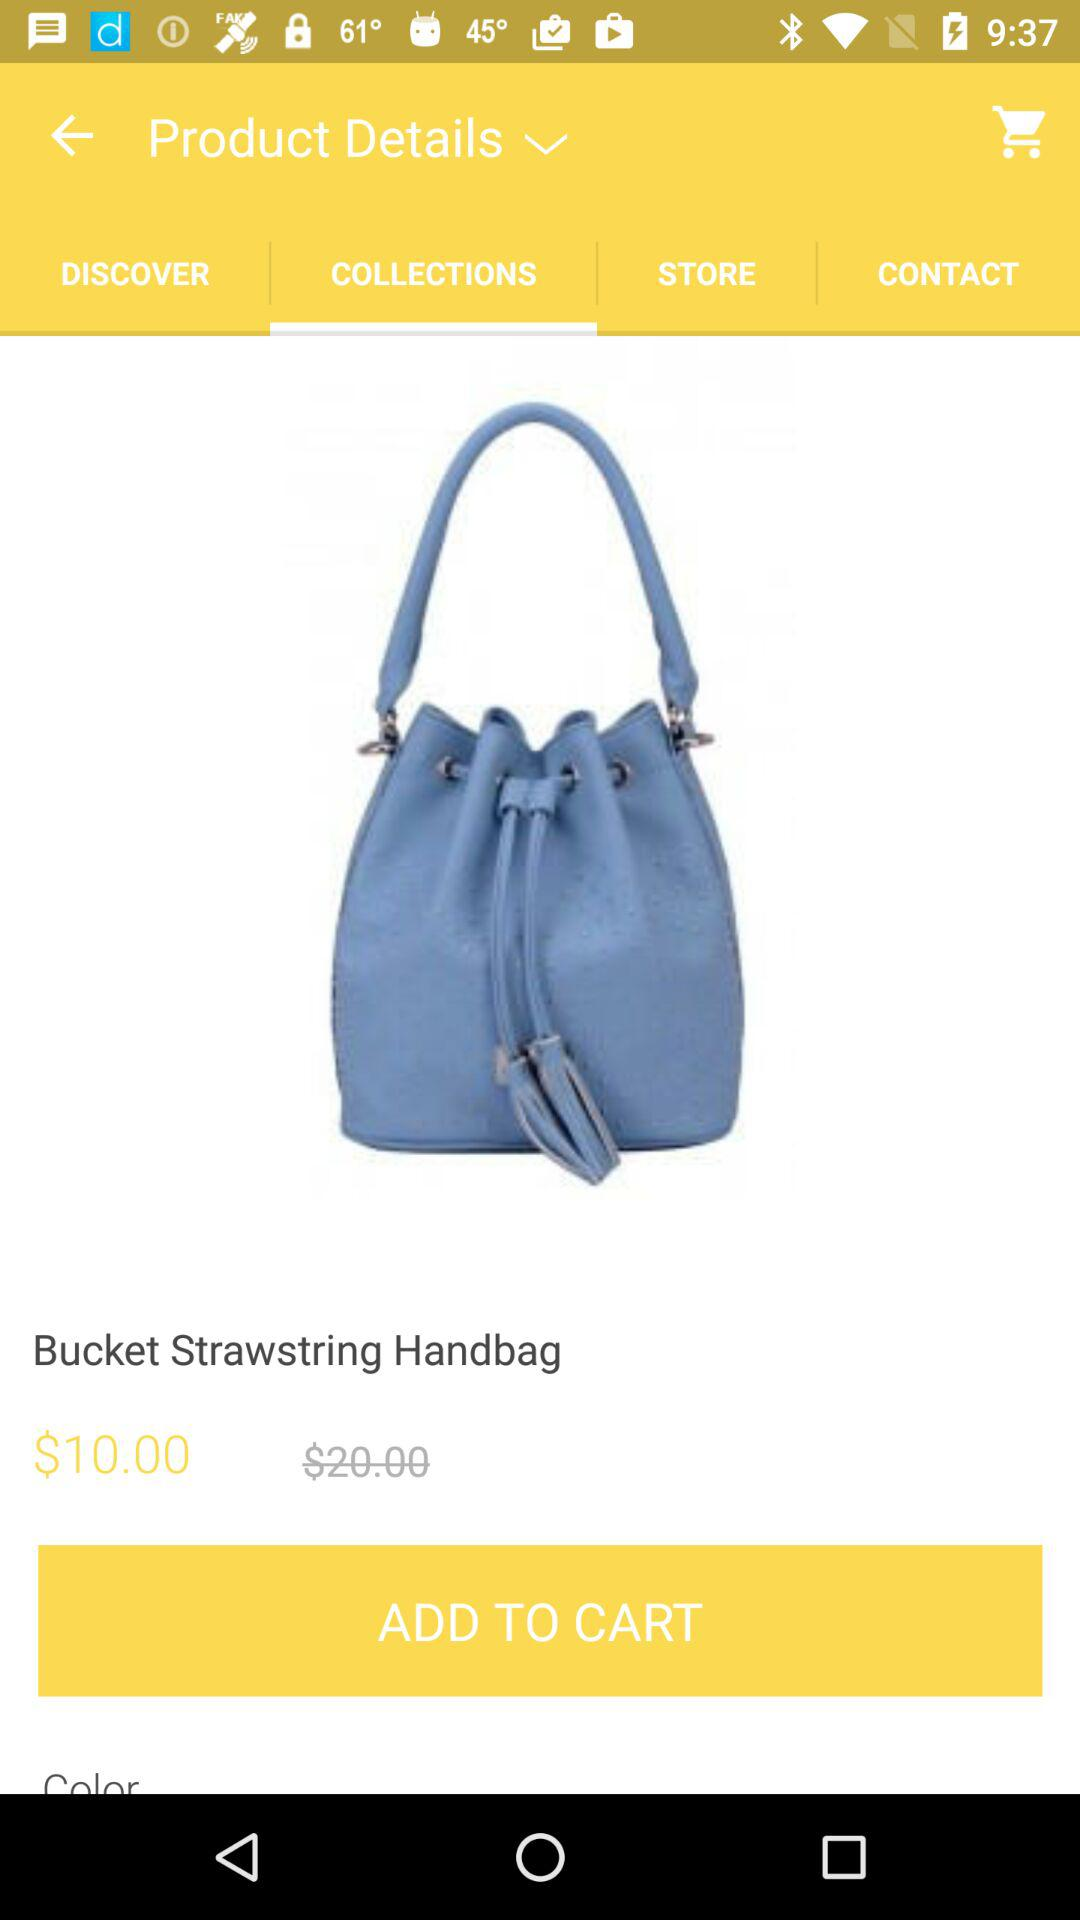How much more is the bucket bag than the price displayed on the product page?
Answer the question using a single word or phrase. $10.00 